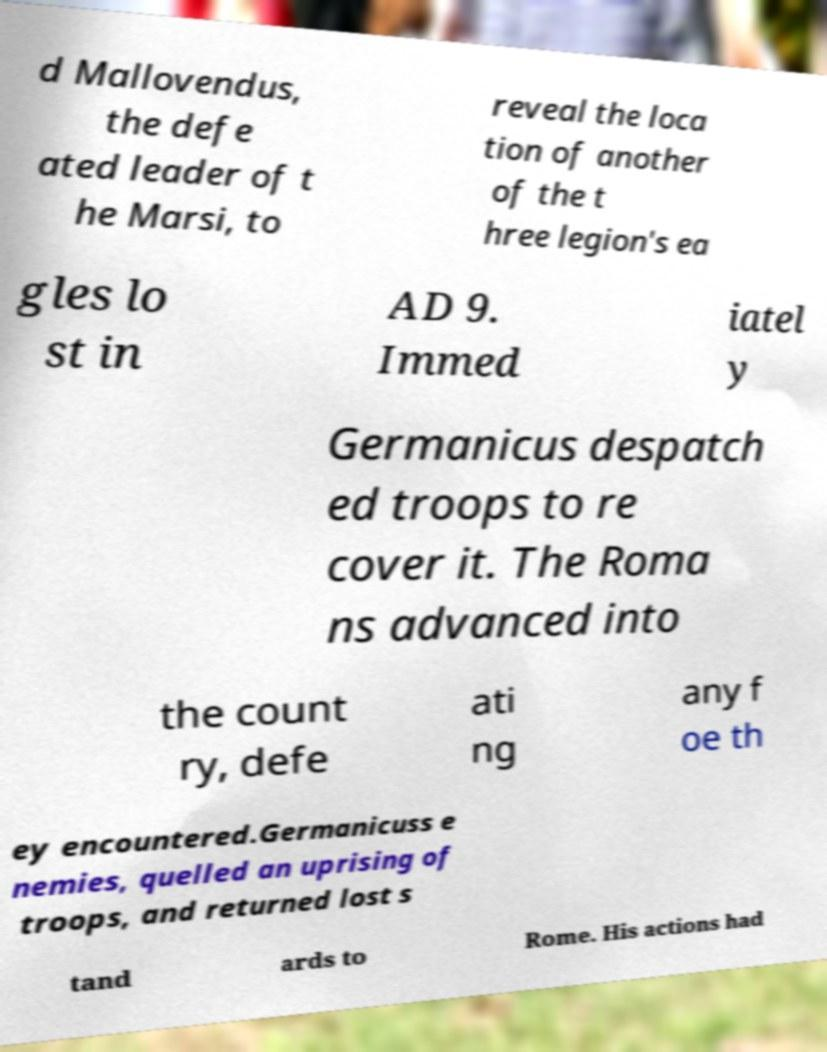What messages or text are displayed in this image? I need them in a readable, typed format. d Mallovendus, the defe ated leader of t he Marsi, to reveal the loca tion of another of the t hree legion's ea gles lo st in AD 9. Immed iatel y Germanicus despatch ed troops to re cover it. The Roma ns advanced into the count ry, defe ati ng any f oe th ey encountered.Germanicuss e nemies, quelled an uprising of troops, and returned lost s tand ards to Rome. His actions had 